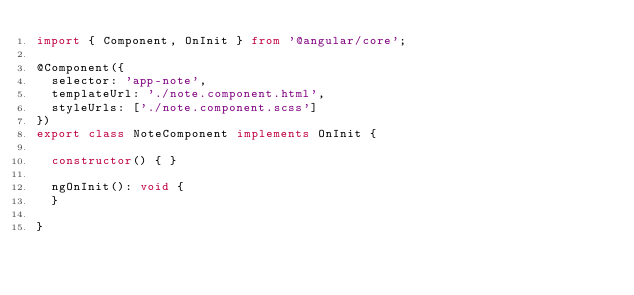Convert code to text. <code><loc_0><loc_0><loc_500><loc_500><_TypeScript_>import { Component, OnInit } from '@angular/core';

@Component({
  selector: 'app-note',
  templateUrl: './note.component.html',
  styleUrls: ['./note.component.scss']
})
export class NoteComponent implements OnInit {

  constructor() { }

  ngOnInit(): void {
  }

}
</code> 